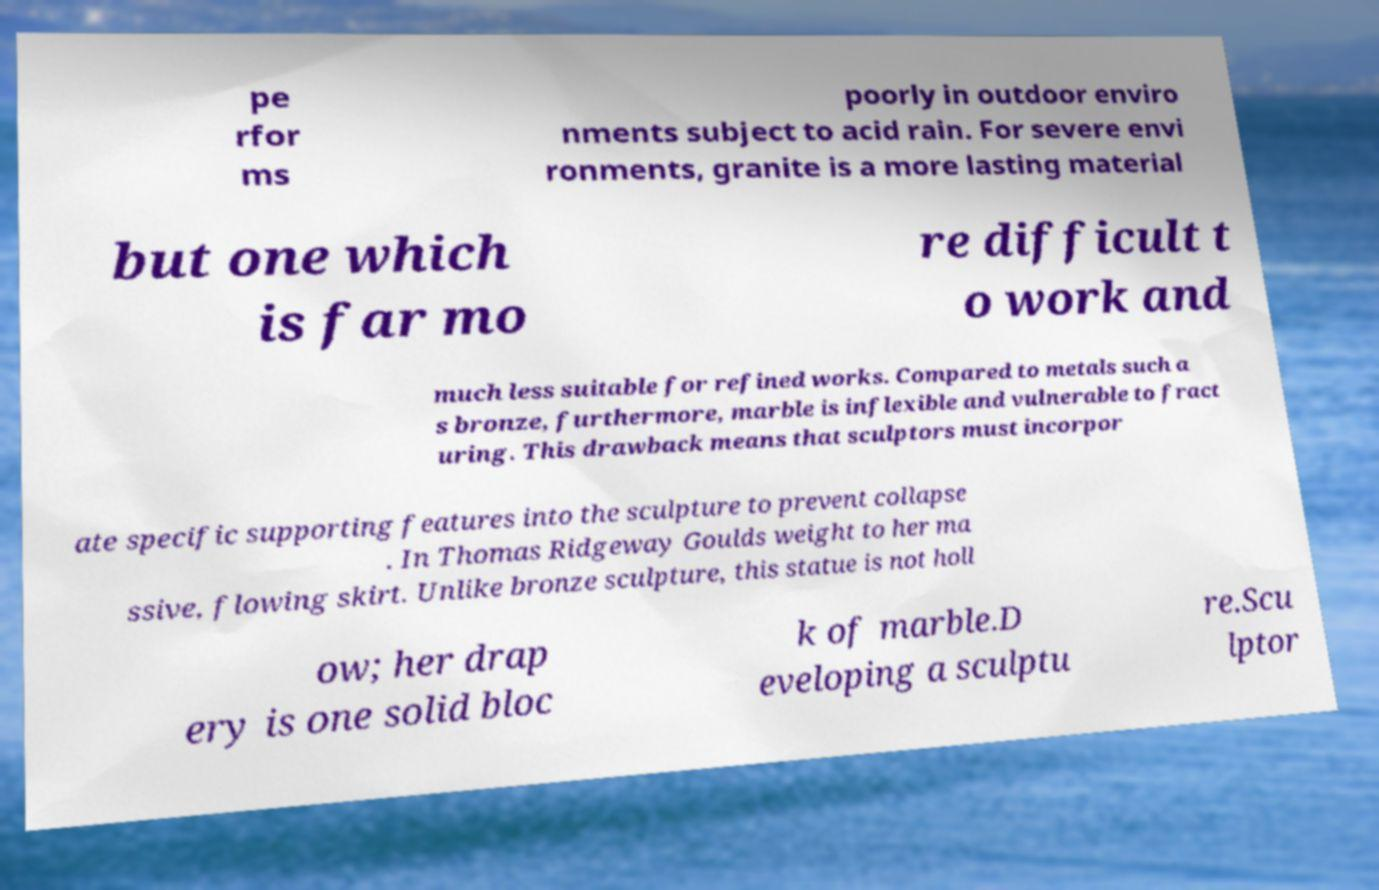Could you assist in decoding the text presented in this image and type it out clearly? pe rfor ms poorly in outdoor enviro nments subject to acid rain. For severe envi ronments, granite is a more lasting material but one which is far mo re difficult t o work and much less suitable for refined works. Compared to metals such a s bronze, furthermore, marble is inflexible and vulnerable to fract uring. This drawback means that sculptors must incorpor ate specific supporting features into the sculpture to prevent collapse . In Thomas Ridgeway Goulds weight to her ma ssive, flowing skirt. Unlike bronze sculpture, this statue is not holl ow; her drap ery is one solid bloc k of marble.D eveloping a sculptu re.Scu lptor 